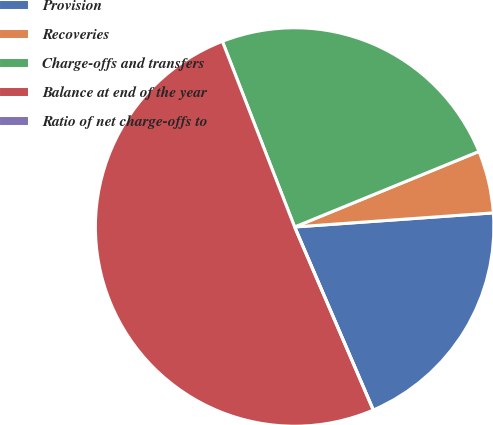Convert chart. <chart><loc_0><loc_0><loc_500><loc_500><pie_chart><fcel>Provision<fcel>Recoveries<fcel>Charge-offs and transfers<fcel>Balance at end of the year<fcel>Ratio of net charge-offs to<nl><fcel>19.67%<fcel>5.06%<fcel>24.72%<fcel>50.55%<fcel>0.0%<nl></chart> 